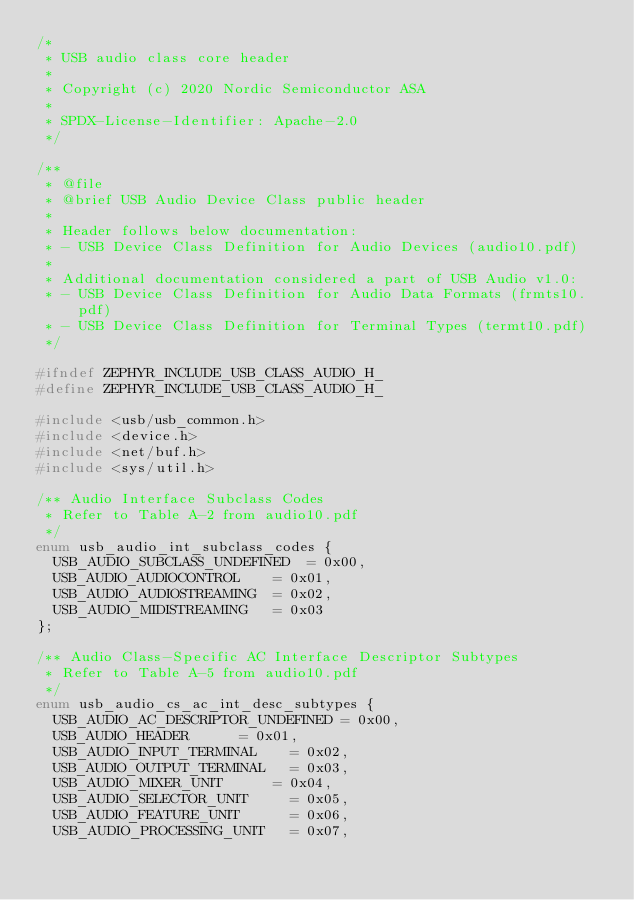Convert code to text. <code><loc_0><loc_0><loc_500><loc_500><_C_>/*
 * USB audio class core header
 *
 * Copyright (c) 2020 Nordic Semiconductor ASA
 *
 * SPDX-License-Identifier: Apache-2.0
 */

/**
 * @file
 * @brief USB Audio Device Class public header
 *
 * Header follows below documentation:
 * - USB Device Class Definition for Audio Devices (audio10.pdf)
 *
 * Additional documentation considered a part of USB Audio v1.0:
 * - USB Device Class Definition for Audio Data Formats (frmts10.pdf)
 * - USB Device Class Definition for Terminal Types (termt10.pdf)
 */

#ifndef ZEPHYR_INCLUDE_USB_CLASS_AUDIO_H_
#define ZEPHYR_INCLUDE_USB_CLASS_AUDIO_H_

#include <usb/usb_common.h>
#include <device.h>
#include <net/buf.h>
#include <sys/util.h>

/** Audio Interface Subclass Codes
 * Refer to Table A-2 from audio10.pdf
 */
enum usb_audio_int_subclass_codes {
	USB_AUDIO_SUBCLASS_UNDEFINED	= 0x00,
	USB_AUDIO_AUDIOCONTROL		= 0x01,
	USB_AUDIO_AUDIOSTREAMING	= 0x02,
	USB_AUDIO_MIDISTREAMING		= 0x03
};

/** Audio Class-Specific AC Interface Descriptor Subtypes
 * Refer to Table A-5 from audio10.pdf
 */
enum usb_audio_cs_ac_int_desc_subtypes {
	USB_AUDIO_AC_DESCRIPTOR_UNDEFINED	= 0x00,
	USB_AUDIO_HEADER			= 0x01,
	USB_AUDIO_INPUT_TERMINAL		= 0x02,
	USB_AUDIO_OUTPUT_TERMINAL		= 0x03,
	USB_AUDIO_MIXER_UNIT			= 0x04,
	USB_AUDIO_SELECTOR_UNIT			= 0x05,
	USB_AUDIO_FEATURE_UNIT			= 0x06,
	USB_AUDIO_PROCESSING_UNIT		= 0x07,</code> 